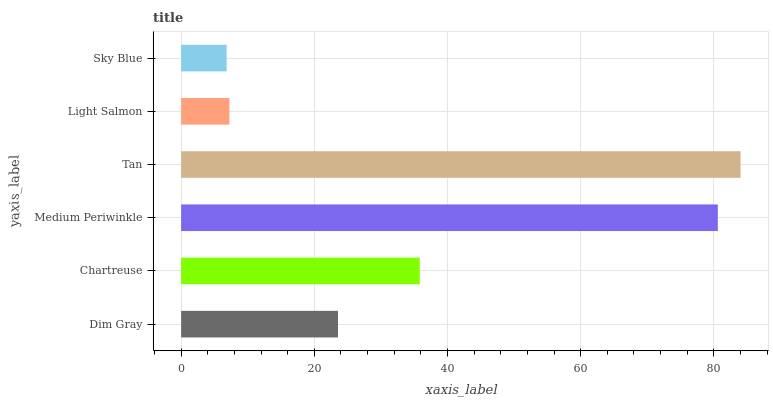Is Sky Blue the minimum?
Answer yes or no. Yes. Is Tan the maximum?
Answer yes or no. Yes. Is Chartreuse the minimum?
Answer yes or no. No. Is Chartreuse the maximum?
Answer yes or no. No. Is Chartreuse greater than Dim Gray?
Answer yes or no. Yes. Is Dim Gray less than Chartreuse?
Answer yes or no. Yes. Is Dim Gray greater than Chartreuse?
Answer yes or no. No. Is Chartreuse less than Dim Gray?
Answer yes or no. No. Is Chartreuse the high median?
Answer yes or no. Yes. Is Dim Gray the low median?
Answer yes or no. Yes. Is Sky Blue the high median?
Answer yes or no. No. Is Chartreuse the low median?
Answer yes or no. No. 